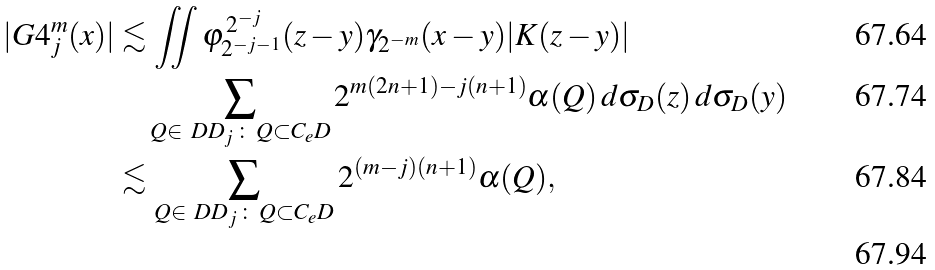Convert formula to latex. <formula><loc_0><loc_0><loc_500><loc_500>| G 4 _ { j } ^ { m } ( x ) | & \lesssim \iint \varphi ^ { \, 2 ^ { - j } } _ { 2 ^ { - j - 1 } } ( z - y ) \gamma _ { 2 ^ { - m } } ( x - y ) | K ( z - y ) | \\ & \quad \sum _ { Q \in \ D D _ { j } \, \colon \, Q \subset C _ { e } D } 2 ^ { m ( 2 n + 1 ) - j ( n + 1 ) } \alpha ( Q ) \, d \sigma _ { D } ( z ) \, d \sigma _ { D } ( y ) \\ & \lesssim \sum _ { Q \in \ D D _ { j } \, \colon \, Q \subset C _ { e } D } 2 ^ { ( m - j ) ( n + 1 ) } \alpha ( Q ) , \\</formula> 